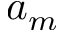<formula> <loc_0><loc_0><loc_500><loc_500>a _ { m }</formula> 